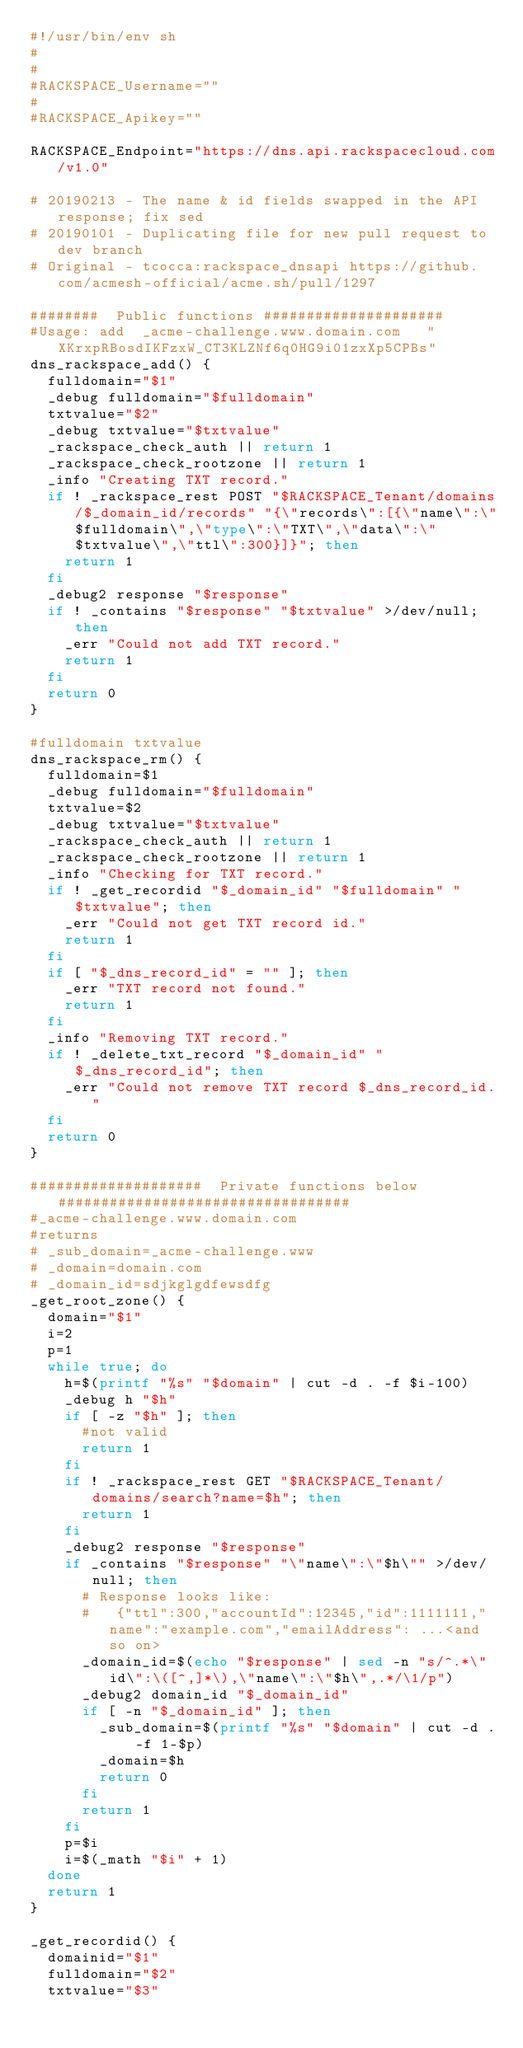<code> <loc_0><loc_0><loc_500><loc_500><_Bash_>#!/usr/bin/env sh
#
#
#RACKSPACE_Username=""
#
#RACKSPACE_Apikey=""

RACKSPACE_Endpoint="https://dns.api.rackspacecloud.com/v1.0"

# 20190213 - The name & id fields swapped in the API response; fix sed
# 20190101 - Duplicating file for new pull request to dev branch
# Original - tcocca:rackspace_dnsapi https://github.com/acmesh-official/acme.sh/pull/1297

########  Public functions #####################
#Usage: add  _acme-challenge.www.domain.com   "XKrxpRBosdIKFzxW_CT3KLZNf6q0HG9i01zxXp5CPBs"
dns_rackspace_add() {
  fulldomain="$1"
  _debug fulldomain="$fulldomain"
  txtvalue="$2"
  _debug txtvalue="$txtvalue"
  _rackspace_check_auth || return 1
  _rackspace_check_rootzone || return 1
  _info "Creating TXT record."
  if ! _rackspace_rest POST "$RACKSPACE_Tenant/domains/$_domain_id/records" "{\"records\":[{\"name\":\"$fulldomain\",\"type\":\"TXT\",\"data\":\"$txtvalue\",\"ttl\":300}]}"; then
    return 1
  fi
  _debug2 response "$response"
  if ! _contains "$response" "$txtvalue" >/dev/null; then
    _err "Could not add TXT record."
    return 1
  fi
  return 0
}

#fulldomain txtvalue
dns_rackspace_rm() {
  fulldomain=$1
  _debug fulldomain="$fulldomain"
  txtvalue=$2
  _debug txtvalue="$txtvalue"
  _rackspace_check_auth || return 1
  _rackspace_check_rootzone || return 1
  _info "Checking for TXT record."
  if ! _get_recordid "$_domain_id" "$fulldomain" "$txtvalue"; then
    _err "Could not get TXT record id."
    return 1
  fi
  if [ "$_dns_record_id" = "" ]; then
    _err "TXT record not found."
    return 1
  fi
  _info "Removing TXT record."
  if ! _delete_txt_record "$_domain_id" "$_dns_record_id"; then
    _err "Could not remove TXT record $_dns_record_id."
  fi
  return 0
}

####################  Private functions below ##################################
#_acme-challenge.www.domain.com
#returns
# _sub_domain=_acme-challenge.www
# _domain=domain.com
# _domain_id=sdjkglgdfewsdfg
_get_root_zone() {
  domain="$1"
  i=2
  p=1
  while true; do
    h=$(printf "%s" "$domain" | cut -d . -f $i-100)
    _debug h "$h"
    if [ -z "$h" ]; then
      #not valid
      return 1
    fi
    if ! _rackspace_rest GET "$RACKSPACE_Tenant/domains/search?name=$h"; then
      return 1
    fi
    _debug2 response "$response"
    if _contains "$response" "\"name\":\"$h\"" >/dev/null; then
      # Response looks like:
      #   {"ttl":300,"accountId":12345,"id":1111111,"name":"example.com","emailAddress": ...<and so on>
      _domain_id=$(echo "$response" | sed -n "s/^.*\"id\":\([^,]*\),\"name\":\"$h\",.*/\1/p")
      _debug2 domain_id "$_domain_id"
      if [ -n "$_domain_id" ]; then
        _sub_domain=$(printf "%s" "$domain" | cut -d . -f 1-$p)
        _domain=$h
        return 0
      fi
      return 1
    fi
    p=$i
    i=$(_math "$i" + 1)
  done
  return 1
}

_get_recordid() {
  domainid="$1"
  fulldomain="$2"
  txtvalue="$3"</code> 